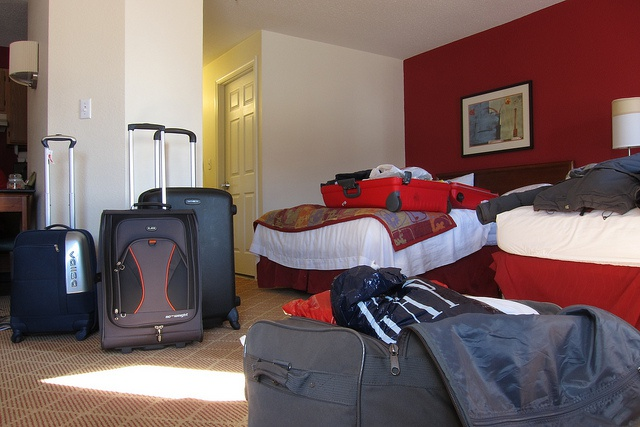Describe the objects in this image and their specific colors. I can see suitcase in black, gray, and darkblue tones, bed in gray, black, darkgray, and maroon tones, bed in black, lightgray, brown, and maroon tones, and suitcase in gray, brown, maroon, and black tones in this image. 